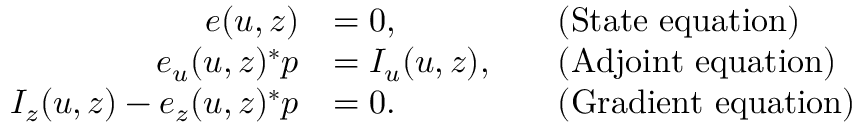Convert formula to latex. <formula><loc_0><loc_0><loc_500><loc_500>\begin{array} { r l r l } { e ( u , z ) } & { = 0 , } & & { ( S t a t e e q u a t i o n ) } \\ { e _ { u } ( u , z ) ^ { * } p } & { = I _ { u } ( u , z ) , } & & { ( A d j o i n t e q u a t i o n ) } \\ { I _ { z } ( u , z ) - e _ { z } ( u , z ) ^ { * } p } & { = 0 . } & & { ( G r a d i e n t e q u a t i o n ) } \end{array}</formula> 